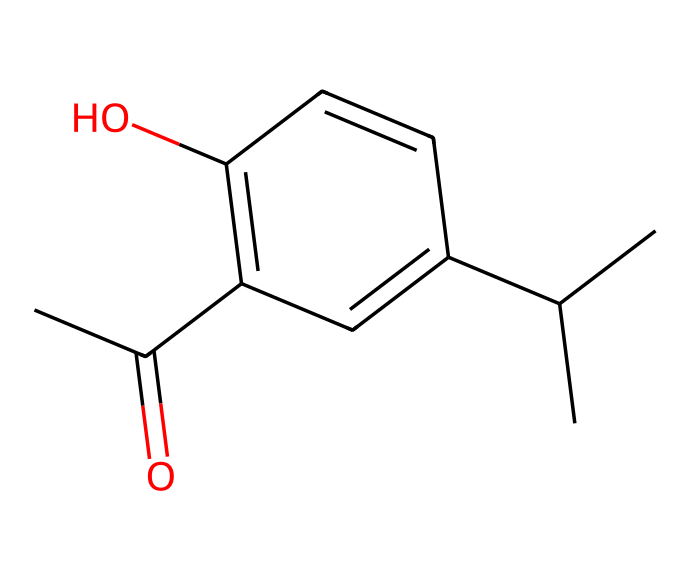What is the total number of carbon atoms in this compound? By examining the SMILES representation, CC(C)C1=CC(=C(C=C1)O)C(C)=O, we can count the carbon (C) atoms. There are 9 carbon atoms in total: 5 in the branched chain (CC(C)), 3 in the ring (C1=CC(C=C1)), and 1 in the carbonyl group (C(C)=O).
Answer: 9 How many oxygen atoms are present in this compound? In the SMILES representation, we can see that there are two occurrences of oxygen (O): one in the hydroxyl group (C=C1)O and one in the carbonyl group (C(C)=O). Thus, the total is 2 oxygen atoms.
Answer: 2 What type of functional groups are identified in this compound? The compound features a hydroxyl group (indicated by -O in the structure) and a carbonyl group (indicated by =O), essential for its flavor characteristics. Therefore, the functional groups are hydroxyl and carbonyl.
Answer: hydroxyl and carbonyl What is the degree of unsaturation in this compound? The degree of unsaturation can be calculated by considering double bonds and rings. There is one double bond in the ring and the presence of a ring itself adds to the unsaturation. Therefore, the degree of unsaturation is at least 1 (from the double bond) plus 1 (for the ring), totaling 2.
Answer: 2 Which part of the structure contributes to the flavor of berbere spice? The presence of the hydroxyl group (-OH) and the carbonyl group (=O) in the structure primarily contributes to the flavor profile of berbere spice, indicating that these functional groups are pivotal in flavor.
Answer: hydroxyl and carbonyl Is this compound likely to be polar or nonpolar? Considering the presence of polar functional groups such as hydroxyl and carbonyl, which can form hydrogen bonds with water, the overall structure suggests that it is polar.
Answer: polar 